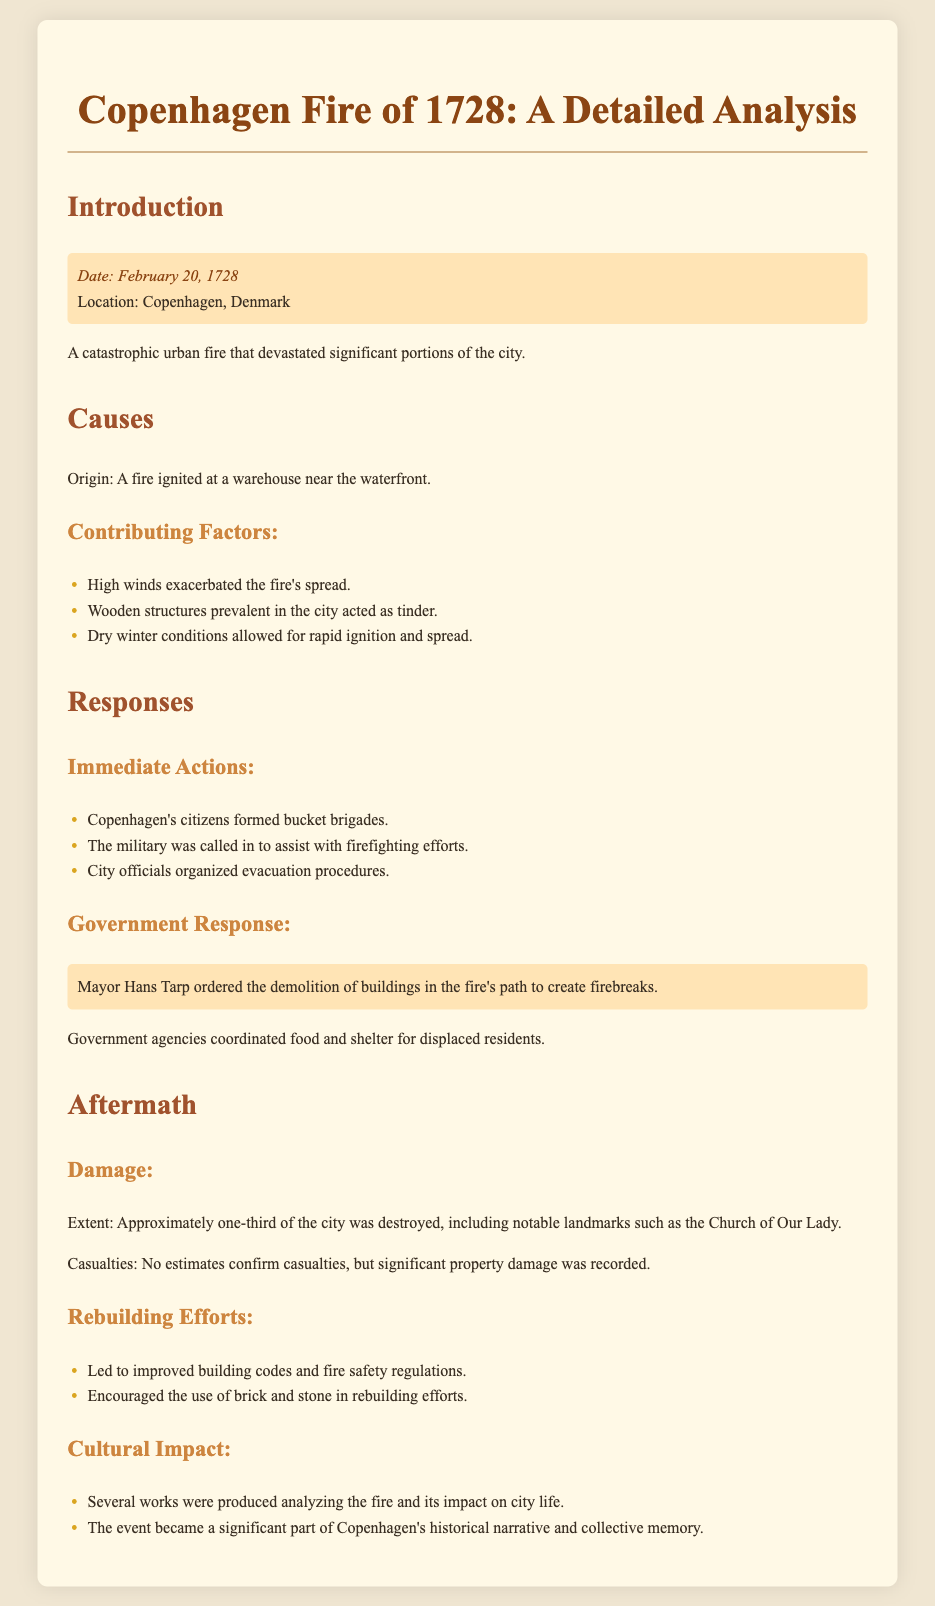What date did the fire occur? The fire occurred on February 20, 1728, as indicated in the introduction section.
Answer: February 20, 1728 What portion of the city was destroyed? The document states that approximately one-third of the city was destroyed.
Answer: One-third What were the immediate actions taken by citizens? The document lists bucket brigades as one of the immediate actions formed by citizens to combat the fire.
Answer: Bucket brigades Who ordered the demolition of buildings? The document specifies that Mayor Hans Tarp ordered the demolition of buildings in the fire's path.
Answer: Mayor Hans Tarp What contributed to the spread of the fire? The causes section identifies high winds as a significant factor that exacerbated the fire's spread.
Answer: High winds What type of structures acted as tinder during the fire? The document notes that wooden structures prevalent in the city acted as tinder.
Answer: Wooden structures What was the cultural impact of the fire? Several works were produced analyzing the fire and its impact on city life, underscoring the cultural significance.
Answer: Works produced What did the rebuilding efforts encourage? The rebuilding efforts led to the encouragement of using brick and stone in rebuilding efforts.
Answer: Brick and stone 